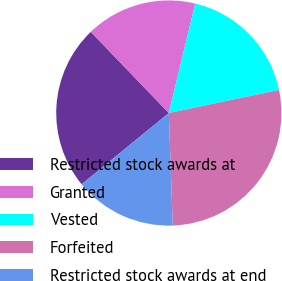Convert chart. <chart><loc_0><loc_0><loc_500><loc_500><pie_chart><fcel>Restricted stock awards at<fcel>Granted<fcel>Vested<fcel>Forfeited<fcel>Restricted stock awards at end<nl><fcel>23.72%<fcel>15.96%<fcel>17.94%<fcel>27.74%<fcel>14.65%<nl></chart> 